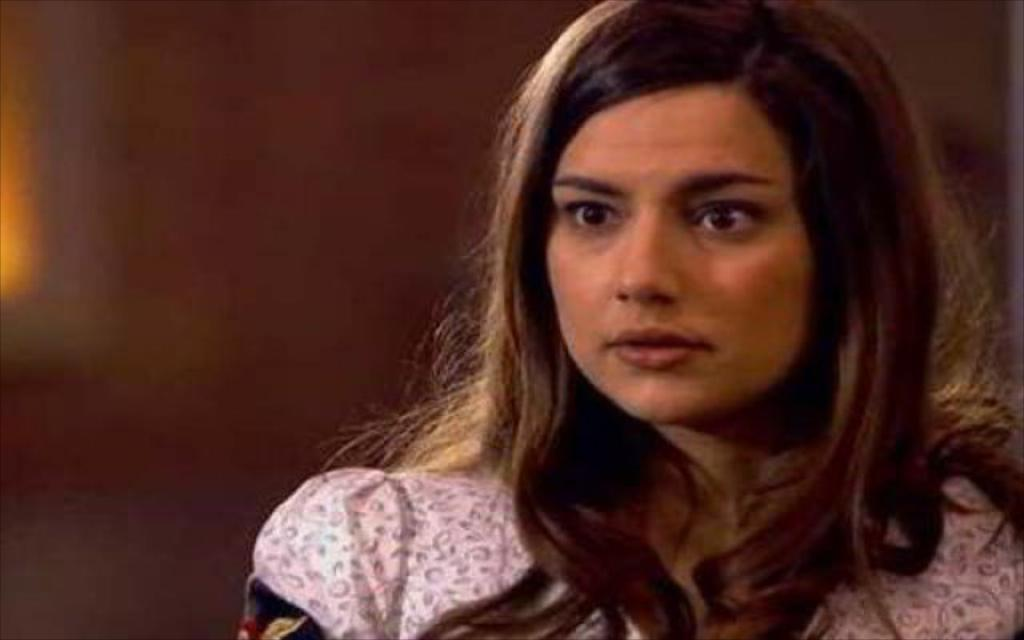Who is present in the image? There is a woman in the image. What can be seen in the background of the image? There is a wall in the background of the image. How many apples are hanging from the woman's trousers in the image? There are no apples or trousers present in the image, as it only features a woman and a wall in the background. 